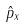<formula> <loc_0><loc_0><loc_500><loc_500>\hat { p } _ { x }</formula> 